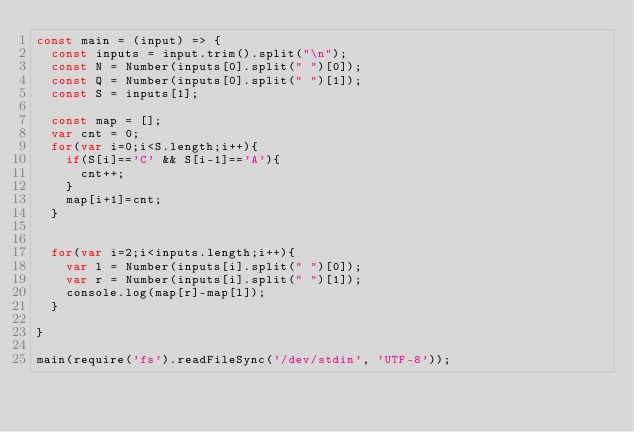Convert code to text. <code><loc_0><loc_0><loc_500><loc_500><_JavaScript_>const main = (input) => {
  const inputs = input.trim().split("\n");
  const N = Number(inputs[0].split(" ")[0]);
  const Q = Number(inputs[0].split(" ")[1]);
  const S = inputs[1];

  const map = [];
  var cnt = 0;
  for(var i=0;i<S.length;i++){
    if(S[i]=='C' && S[i-1]=='A'){
      cnt++;
    }
    map[i+1]=cnt;
  }


  for(var i=2;i<inputs.length;i++){
    var l = Number(inputs[i].split(" ")[0]);
    var r = Number(inputs[i].split(" ")[1]);
    console.log(map[r]-map[l]);
  }

}

main(require('fs').readFileSync('/dev/stdin', 'UTF-8'));
</code> 